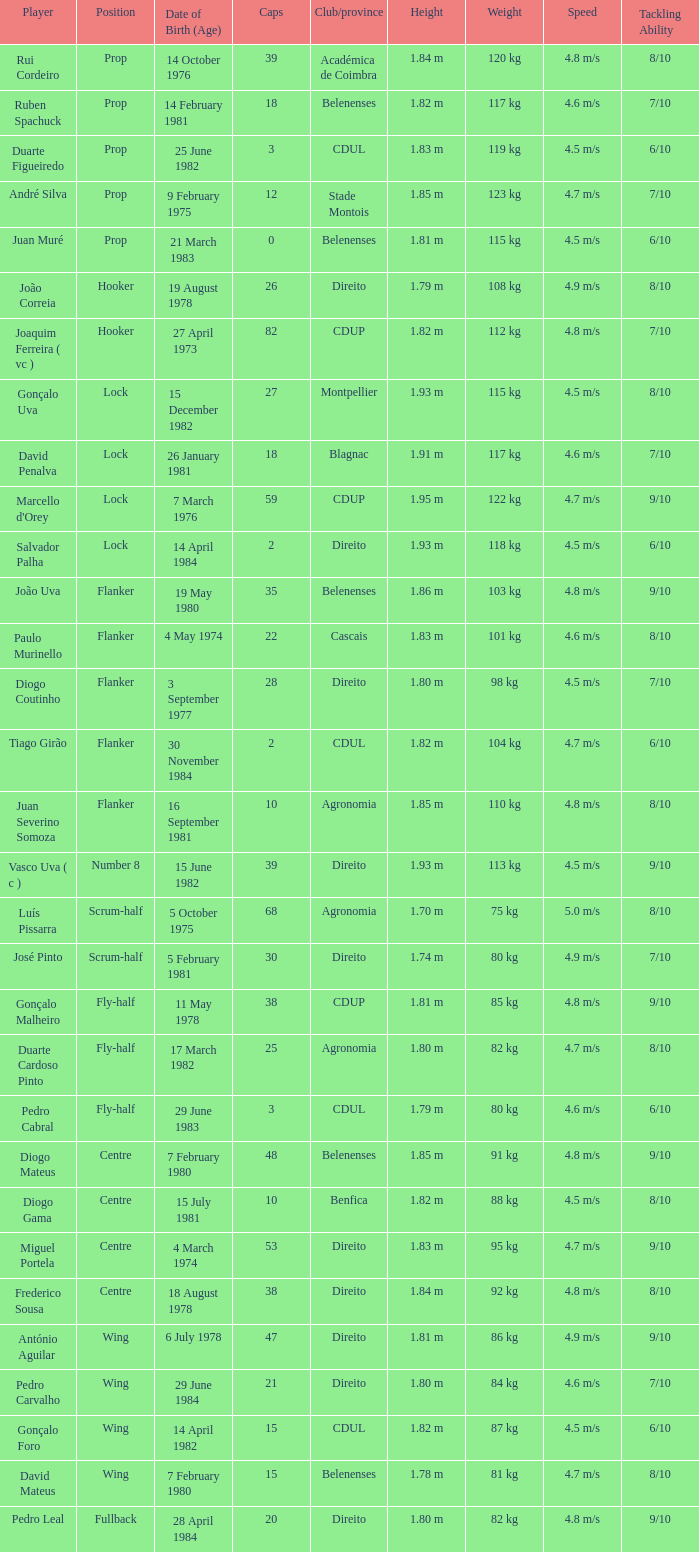Which player has a Club/province of direito, less than 21 caps, and a Position of lock? Salvador Palha. 